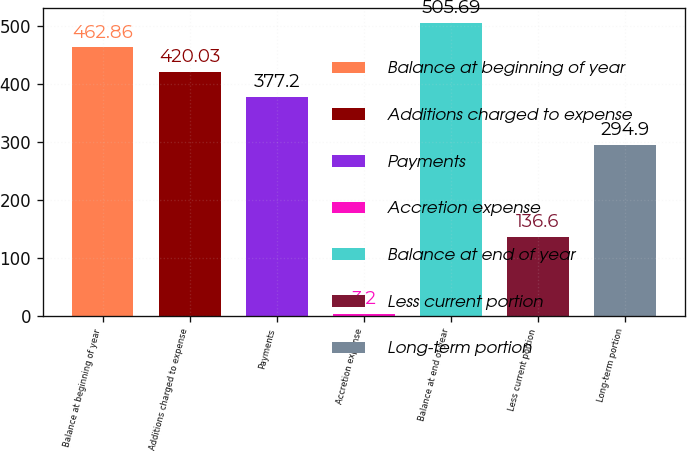<chart> <loc_0><loc_0><loc_500><loc_500><bar_chart><fcel>Balance at beginning of year<fcel>Additions charged to expense<fcel>Payments<fcel>Accretion expense<fcel>Balance at end of year<fcel>Less current portion<fcel>Long-term portion<nl><fcel>462.86<fcel>420.03<fcel>377.2<fcel>3.2<fcel>505.69<fcel>136.6<fcel>294.9<nl></chart> 